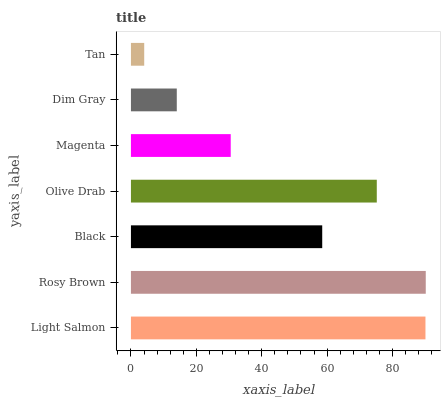Is Tan the minimum?
Answer yes or no. Yes. Is Rosy Brown the maximum?
Answer yes or no. Yes. Is Black the minimum?
Answer yes or no. No. Is Black the maximum?
Answer yes or no. No. Is Rosy Brown greater than Black?
Answer yes or no. Yes. Is Black less than Rosy Brown?
Answer yes or no. Yes. Is Black greater than Rosy Brown?
Answer yes or no. No. Is Rosy Brown less than Black?
Answer yes or no. No. Is Black the high median?
Answer yes or no. Yes. Is Black the low median?
Answer yes or no. Yes. Is Olive Drab the high median?
Answer yes or no. No. Is Light Salmon the low median?
Answer yes or no. No. 